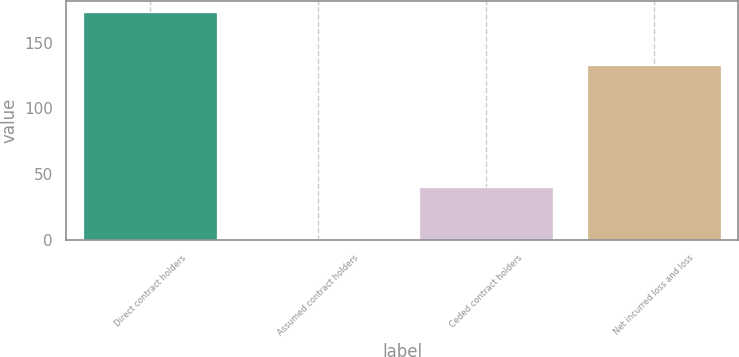<chart> <loc_0><loc_0><loc_500><loc_500><bar_chart><fcel>Direct contract holders<fcel>Assumed contract holders<fcel>Ceded contract holders<fcel>Net incurred loss and loss<nl><fcel>173<fcel>0.16<fcel>40<fcel>133<nl></chart> 